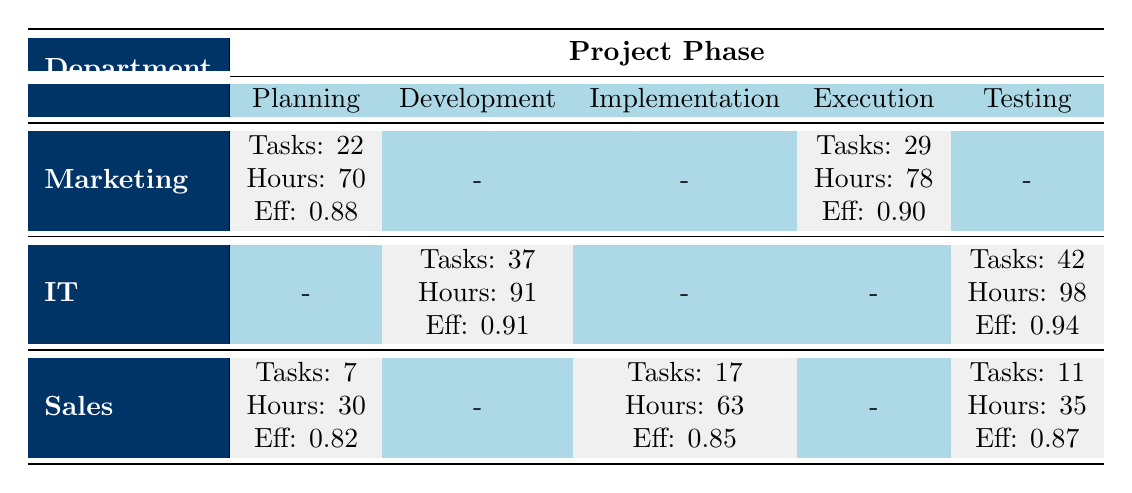What is the total number of tasks completed by the Marketing department? The Marketing department has two phases where tasks are recorded: Planning (22 tasks) and Execution (29 tasks). Summing the tasks gives 22 + 29 = 51.
Answer: 51 Which department has the highest efficiency score in the Testing phase? In the Testing phase, the IT department scored an efficiency of 0.94, while the Marketing and Sales departments have no entries for this phase. Therefore, the highest efficiency score in Testing is from IT.
Answer: IT What is the average hours worked by the employees in the Sales department across all project phases? In the Sales department, the hours worked across phases are: Planning (30 hours), Implementation (31 hours), and Evaluation (35 hours). The average is calculated by summing 30 + 31 + 35 = 96 and dividing by 3 (the number of phases), resulting in an average of 32 hours.
Answer: 32 Did any employee in the IT department complete more than 20 tasks in any phase? The IT department's employees have the following tasks completed: 0 in Planning, 37 in Development, and 42 in Testing. Since both 37 and 42 are more than 20, the answer is yes.
Answer: Yes What is the efficiency score difference between the highest and lowest efficiency scores in the Marketing department? The efficiencies in the Marketing department are 0.88 in Planning and 0.90 in Execution. The highest score is 0.90, and the lowest is 0.88. The difference is calculated as 0.90 - 0.88 = 0.02.
Answer: 0.02 